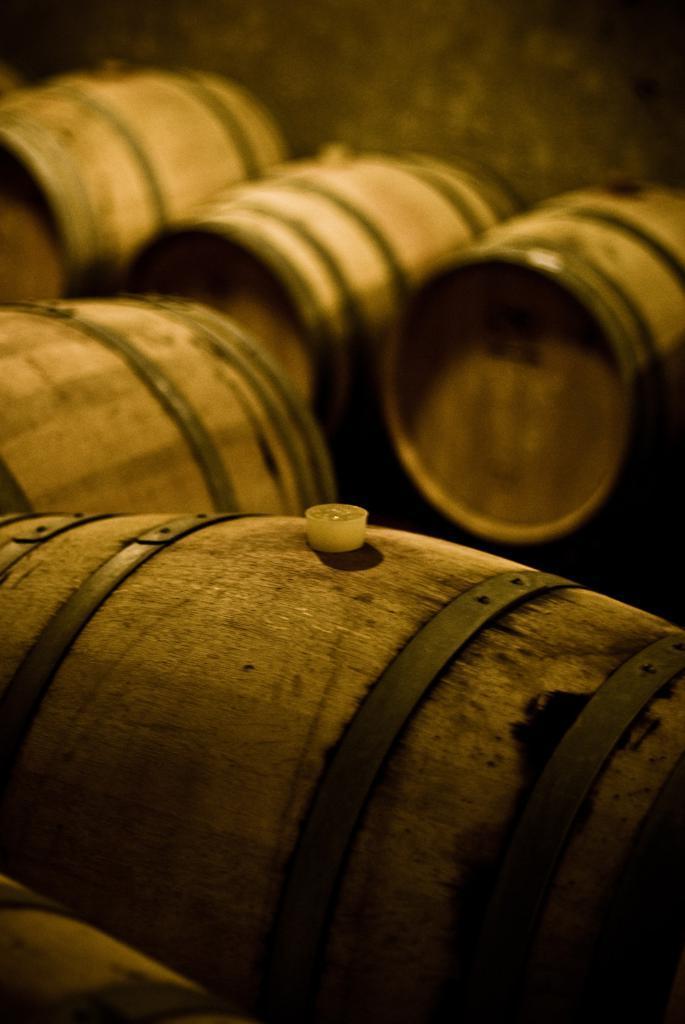In one or two sentences, can you explain what this image depicts? In this image I can see few wooden barrels which are brown in color and I can see a cork to the barrel. I can see the blurry background. 